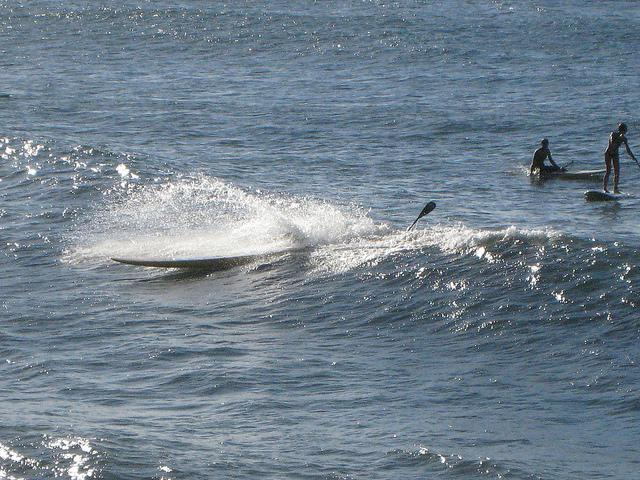What is below the paddle shown here? water 